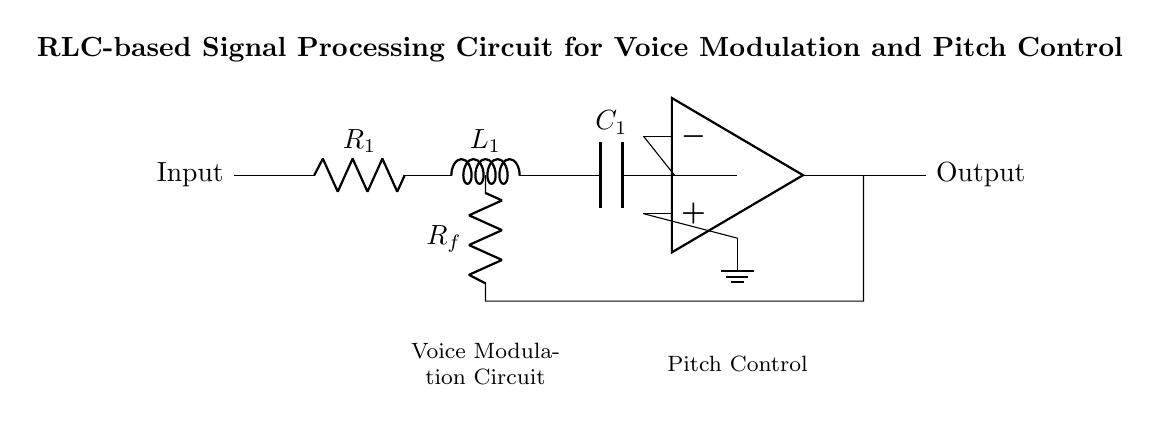What type of circuit is represented? The circuit is an RLC circuit, indicated by the presence of the components: a resistor, an inductor, and a capacitor arranged in series.
Answer: RLC circuit What does R1 represent in the circuit? R1 represents the resistance, which is essential for controlling the current flow in the circuit and is labeled directly on the diagram.
Answer: Resistor What is the function of L1 in this circuit? L1 is an inductor whose primary function is to store energy in a magnetic field when current flows through it. It also affects the circuit's response to changing signals.
Answer: Store energy What is the role of the amplifier in this circuit? The amplifier boosts the signal strength of the processed input to ensure that the output is adequate for voice modulation and pitch control applications.
Answer: Boost signal strength How do R1, L1, and C1 work together? R1, L1, and C1 create a resonant circuit that can filter specific frequencies, enhancing voice modulation and controlling pitch in the audio signal. Their combined effects control the timing and frequency response of the circuit.
Answer: Create resonant circuit What is the purpose of the feedback resistor Rf? Rf provides negative feedback to the amplifier, which stabilizes gain and improves the linearity of the output signal, enhancing the overall performance of the circuit.
Answer: Stabilize gain What kind of output does this circuit provide? The output provides a modulated and pitch-controlled audio signal that can be used for clearer vocal transmission, particularly beneficial in public speaking contexts.
Answer: Modulated audio signal 